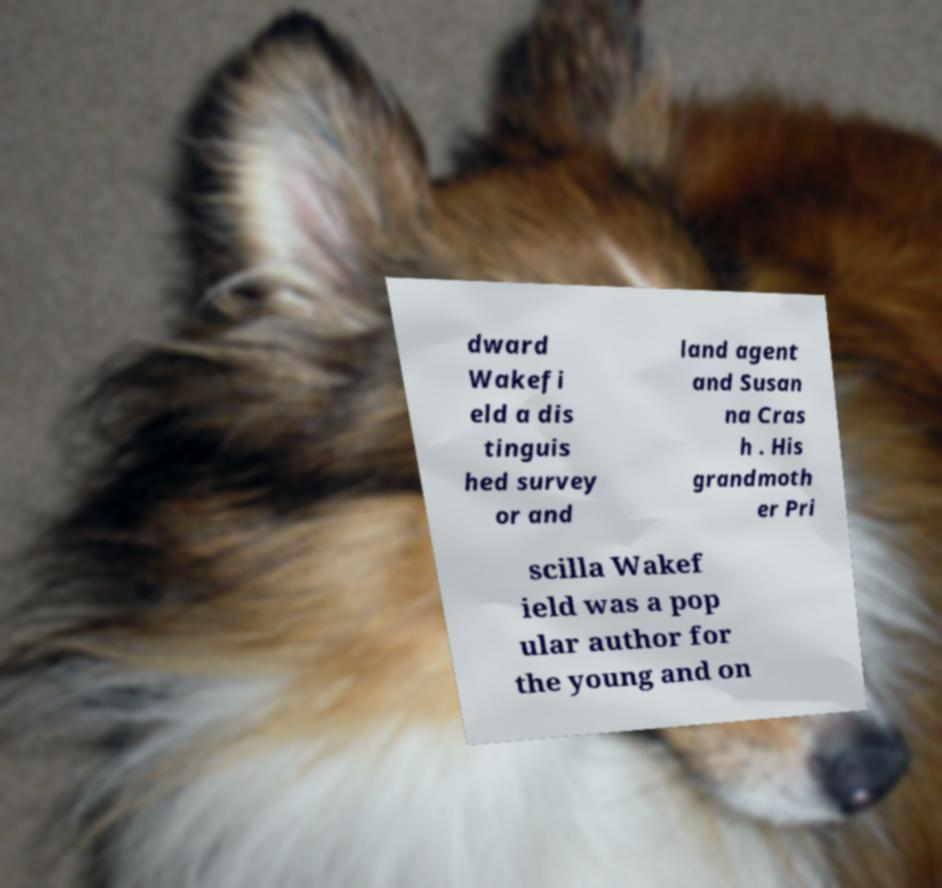Could you assist in decoding the text presented in this image and type it out clearly? dward Wakefi eld a dis tinguis hed survey or and land agent and Susan na Cras h . His grandmoth er Pri scilla Wakef ield was a pop ular author for the young and on 